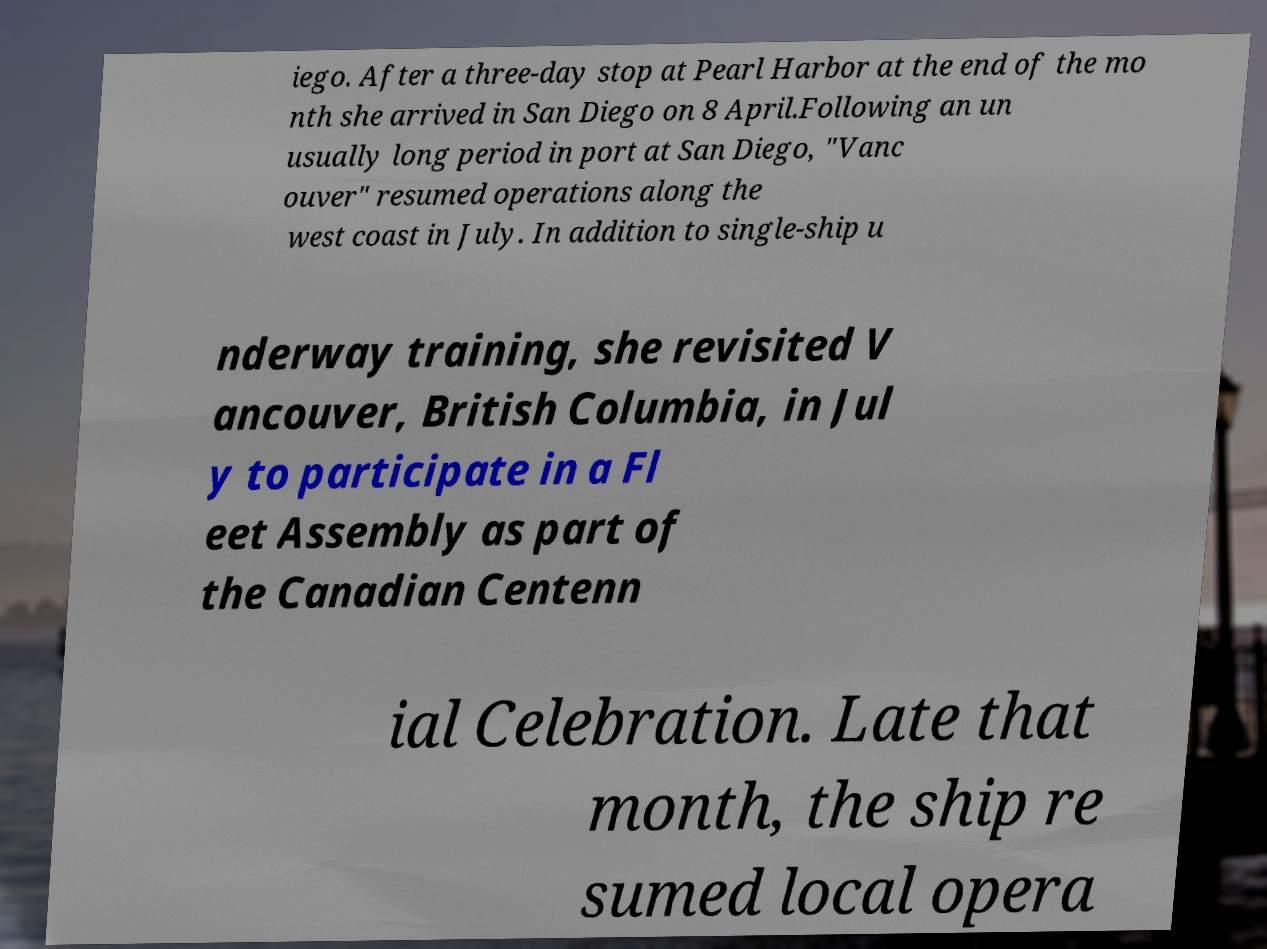I need the written content from this picture converted into text. Can you do that? iego. After a three-day stop at Pearl Harbor at the end of the mo nth she arrived in San Diego on 8 April.Following an un usually long period in port at San Diego, "Vanc ouver" resumed operations along the west coast in July. In addition to single-ship u nderway training, she revisited V ancouver, British Columbia, in Jul y to participate in a Fl eet Assembly as part of the Canadian Centenn ial Celebration. Late that month, the ship re sumed local opera 